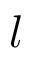Convert formula to latex. <formula><loc_0><loc_0><loc_500><loc_500>l</formula> 